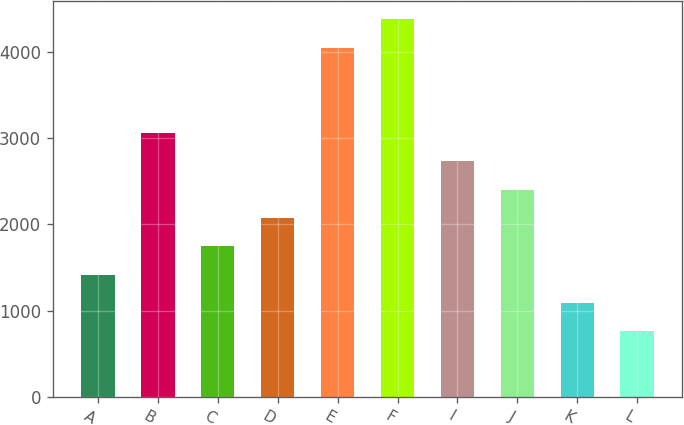Convert chart to OTSL. <chart><loc_0><loc_0><loc_500><loc_500><bar_chart><fcel>A<fcel>B<fcel>C<fcel>D<fcel>E<fcel>F<fcel>I<fcel>J<fcel>K<fcel>L<nl><fcel>1416.88<fcel>3059.08<fcel>1745.32<fcel>2073.76<fcel>4044.44<fcel>4372.88<fcel>2730.64<fcel>2402.2<fcel>1088.44<fcel>760<nl></chart> 